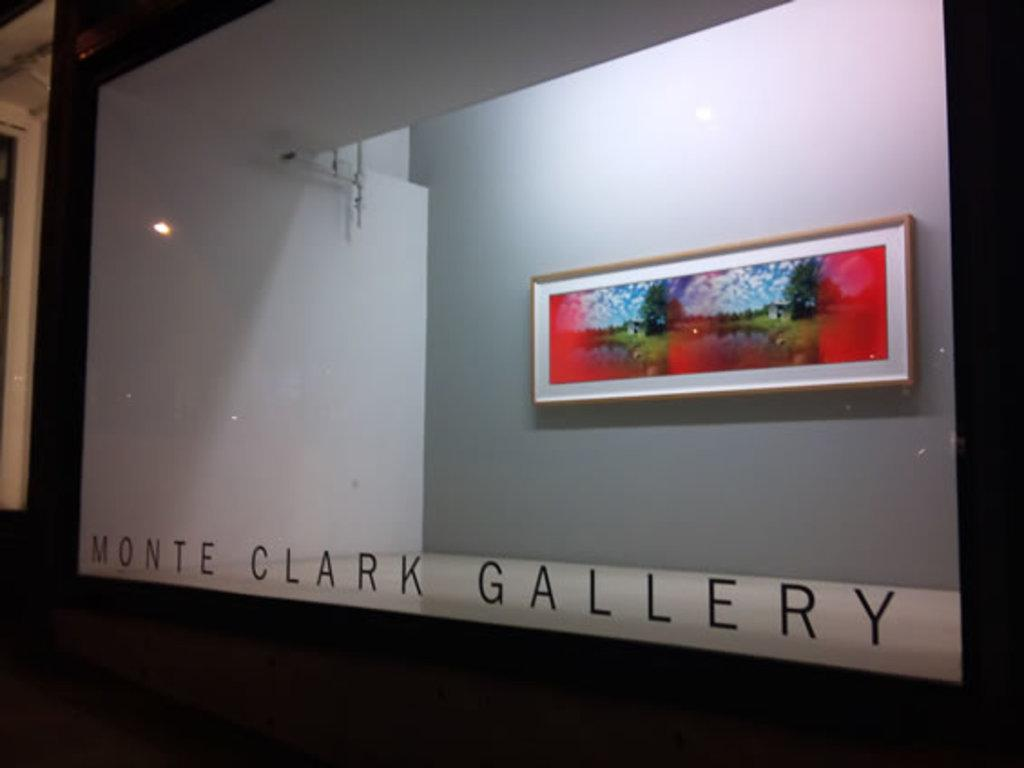What object is present in the image that can hold a liquid? There is a glass in the image. What can be seen through the glass in the image? A photo frame is visible through the glass. Where is the photo frame located in the image? The photo frame is on a wall. What type of nerve can be seen in the image? There is no nerve present in the image; it features a glass and a photo frame. Can you tell me how much the tramp costs in the image? There is no tramp or any item related to a tramp in the image. 